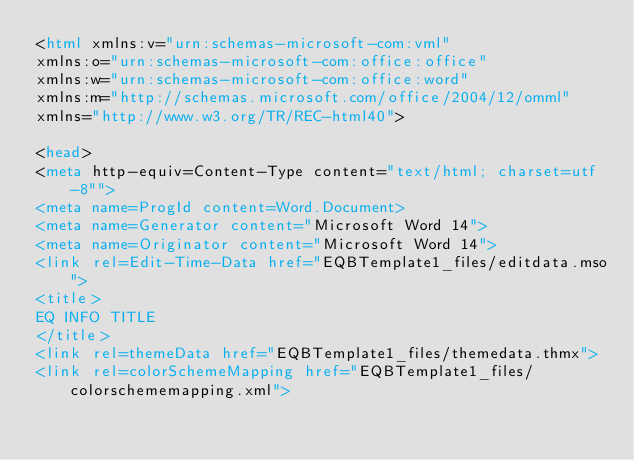<code> <loc_0><loc_0><loc_500><loc_500><_HTML_><html xmlns:v="urn:schemas-microsoft-com:vml"
xmlns:o="urn:schemas-microsoft-com:office:office"
xmlns:w="urn:schemas-microsoft-com:office:word"
xmlns:m="http://schemas.microsoft.com/office/2004/12/omml"
xmlns="http://www.w3.org/TR/REC-html40">

<head>
<meta http-equiv=Content-Type content="text/html; charset=utf-8"">
<meta name=ProgId content=Word.Document>
<meta name=Generator content="Microsoft Word 14">
<meta name=Originator content="Microsoft Word 14">
<link rel=Edit-Time-Data href="EQBTemplate1_files/editdata.mso">
<title>
EQ INFO TITLE
</title>
<link rel=themeData href="EQBTemplate1_files/themedata.thmx">
<link rel=colorSchemeMapping href="EQBTemplate1_files/colorschememapping.xml"></code> 